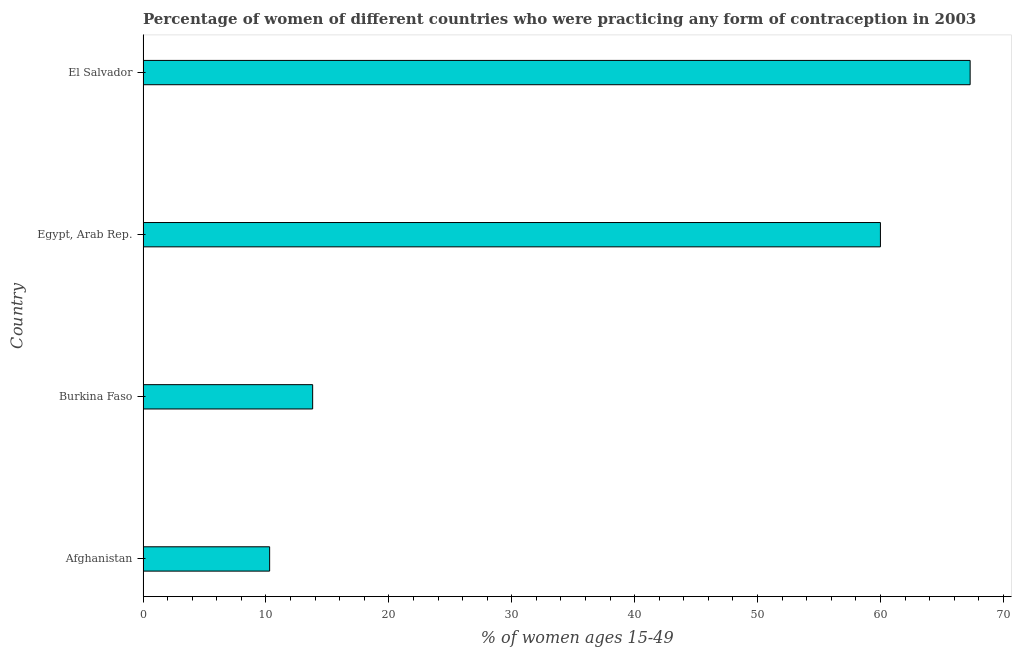What is the title of the graph?
Provide a short and direct response. Percentage of women of different countries who were practicing any form of contraception in 2003. What is the label or title of the X-axis?
Your answer should be very brief. % of women ages 15-49. Across all countries, what is the maximum contraceptive prevalence?
Keep it short and to the point. 67.3. Across all countries, what is the minimum contraceptive prevalence?
Make the answer very short. 10.3. In which country was the contraceptive prevalence maximum?
Provide a succinct answer. El Salvador. In which country was the contraceptive prevalence minimum?
Give a very brief answer. Afghanistan. What is the sum of the contraceptive prevalence?
Offer a terse response. 151.4. What is the difference between the contraceptive prevalence in Afghanistan and El Salvador?
Ensure brevity in your answer.  -57. What is the average contraceptive prevalence per country?
Keep it short and to the point. 37.85. What is the median contraceptive prevalence?
Your answer should be compact. 36.9. What is the ratio of the contraceptive prevalence in Afghanistan to that in El Salvador?
Provide a succinct answer. 0.15. Is the contraceptive prevalence in Burkina Faso less than that in Egypt, Arab Rep.?
Provide a short and direct response. Yes. What is the difference between the highest and the second highest contraceptive prevalence?
Make the answer very short. 7.3. Is the sum of the contraceptive prevalence in Afghanistan and Burkina Faso greater than the maximum contraceptive prevalence across all countries?
Give a very brief answer. No. What is the difference between the highest and the lowest contraceptive prevalence?
Provide a short and direct response. 57. How many bars are there?
Your answer should be very brief. 4. How many countries are there in the graph?
Offer a terse response. 4. What is the difference between two consecutive major ticks on the X-axis?
Provide a short and direct response. 10. What is the % of women ages 15-49 in Afghanistan?
Provide a succinct answer. 10.3. What is the % of women ages 15-49 of Burkina Faso?
Your answer should be compact. 13.8. What is the % of women ages 15-49 of Egypt, Arab Rep.?
Your answer should be very brief. 60. What is the % of women ages 15-49 of El Salvador?
Your answer should be compact. 67.3. What is the difference between the % of women ages 15-49 in Afghanistan and Burkina Faso?
Provide a short and direct response. -3.5. What is the difference between the % of women ages 15-49 in Afghanistan and Egypt, Arab Rep.?
Keep it short and to the point. -49.7. What is the difference between the % of women ages 15-49 in Afghanistan and El Salvador?
Your answer should be very brief. -57. What is the difference between the % of women ages 15-49 in Burkina Faso and Egypt, Arab Rep.?
Your answer should be compact. -46.2. What is the difference between the % of women ages 15-49 in Burkina Faso and El Salvador?
Provide a succinct answer. -53.5. What is the ratio of the % of women ages 15-49 in Afghanistan to that in Burkina Faso?
Provide a short and direct response. 0.75. What is the ratio of the % of women ages 15-49 in Afghanistan to that in Egypt, Arab Rep.?
Give a very brief answer. 0.17. What is the ratio of the % of women ages 15-49 in Afghanistan to that in El Salvador?
Offer a very short reply. 0.15. What is the ratio of the % of women ages 15-49 in Burkina Faso to that in Egypt, Arab Rep.?
Keep it short and to the point. 0.23. What is the ratio of the % of women ages 15-49 in Burkina Faso to that in El Salvador?
Keep it short and to the point. 0.2. What is the ratio of the % of women ages 15-49 in Egypt, Arab Rep. to that in El Salvador?
Provide a short and direct response. 0.89. 